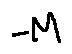Convert formula to latex. <formula><loc_0><loc_0><loc_500><loc_500>- M</formula> 